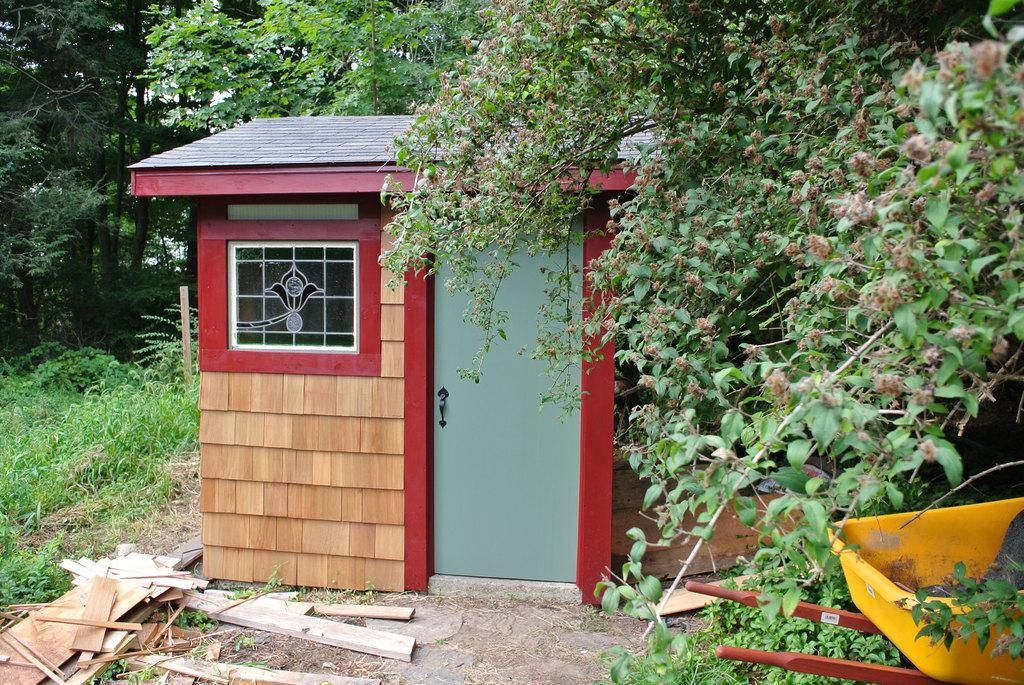Describe this image in one or two sentences. In this image I can see it is a wooden house has door window. On the right side there is a plastic tub in yellow color. These are the two iron rods, there are trees in this image. At the bottom there are wooden planks on the floor. 